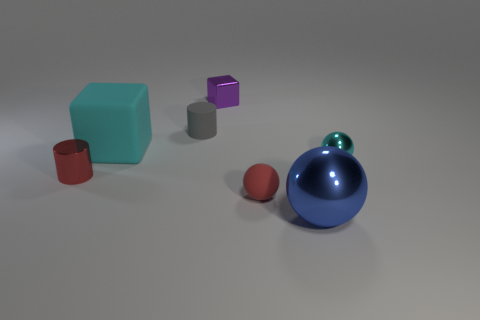Do the tiny rubber sphere and the shiny cylinder have the same color?
Your response must be concise. Yes. The block that is the same color as the small metal sphere is what size?
Offer a terse response. Large. Is the material of the red thing right of the purple block the same as the small gray object?
Provide a short and direct response. Yes. There is a matte cylinder that is the same size as the purple thing; what color is it?
Keep it short and to the point. Gray. The small sphere that is left of the blue shiny thing is what color?
Make the answer very short. Red. There is a thing that is the same color as the matte sphere; what is its shape?
Your answer should be compact. Cylinder. How many matte cylinders are the same size as the cyan matte cube?
Provide a succinct answer. 0. The metallic object that is both to the right of the big cyan cube and on the left side of the small red matte sphere is what color?
Your answer should be very brief. Purple. How many things are cyan shiny things or tiny gray cylinders?
Make the answer very short. 2. How many tiny things are either cylinders or purple blocks?
Your answer should be very brief. 3. 